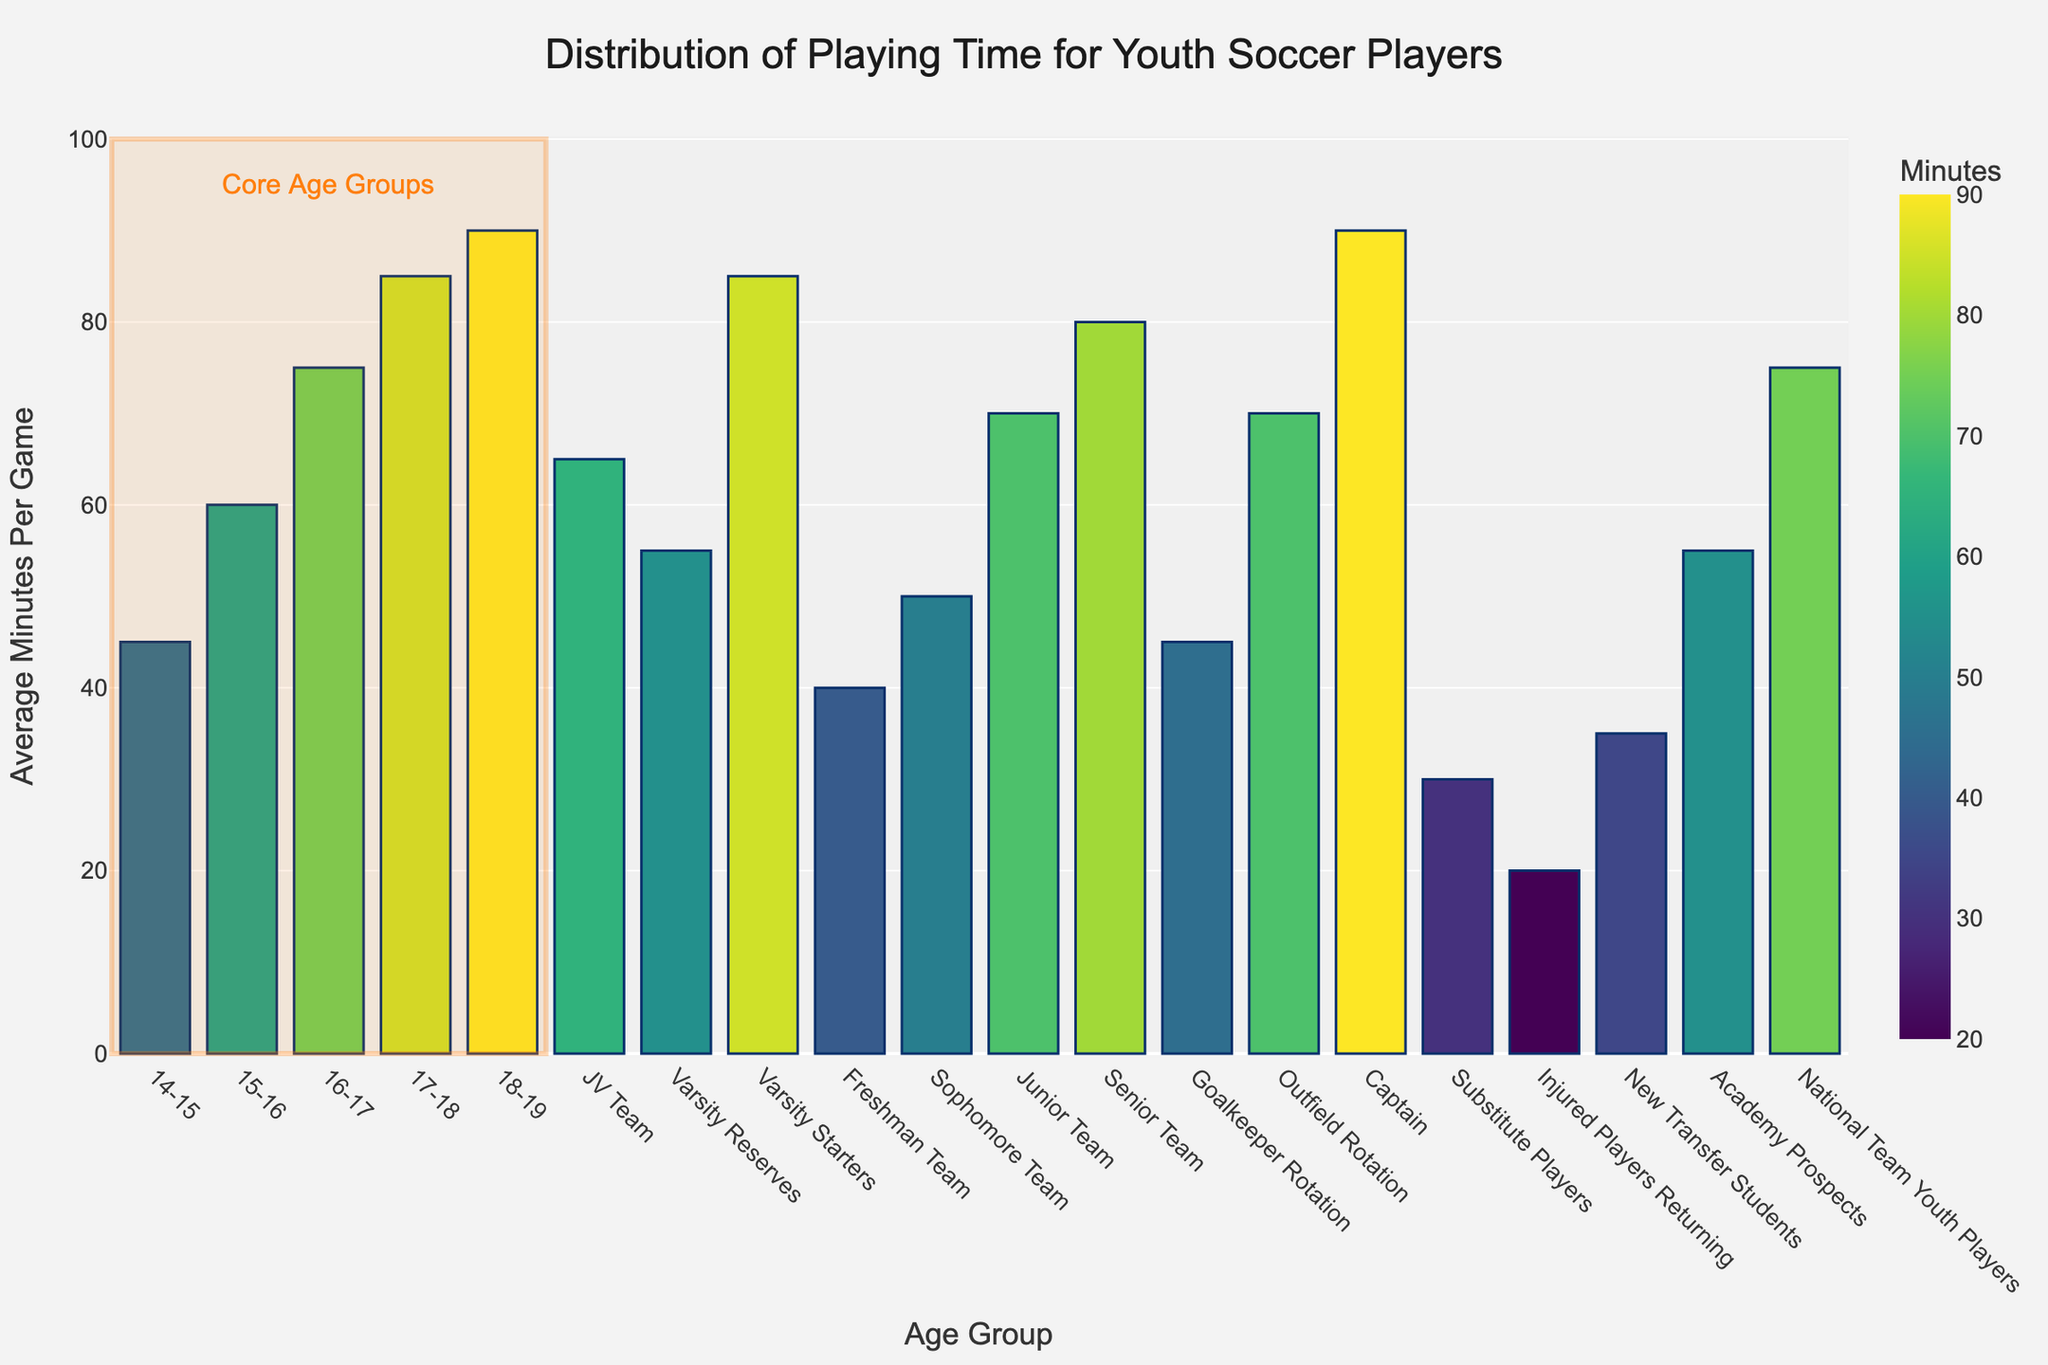What's the range of average minutes played for age-based groups? To find the range for age-based groups, identify the minimum and maximum average minutes played. The minimum is 45 (for 14-15) and the maximum is 90 (for 18-19). The range is 90 - 45.
Answer: 45 minutes Which group plays the least amount of minutes on average? Locate the bar with the smallest value on the y-axis. "Injured Players Returning" have the smallest bar, representing 20 average minutes played per game.
Answer: Injured Players Returning How much more do National Team Youth Players play compared to New Transfer Students? Find the averages for both groups: National Team Youth Players (75) and New Transfer Students (35). Subtract the smaller value from the larger: 75 - 35.
Answer: 40 minutes What is the average playing time for all the groups combined? Calculate the average by summing all the average values and dividing by the number of groups. Total sum = 45 + 60 + 75 + 85 + 90 + 65 + 55 + 85 + 40 + 50 + 70 + 80 + 45 + 70 + 90 + 30 + 20 + 35 + 55 + 75 = 1110. Number of groups = 20. Average = 1110 / 20
Answer: 55.5 minutes What is the difference in average playing time between JV Team and Varsity Reserves? Find the difference between the averages: JV Team (65) and Varsity Reserves (55). Subtract: 65 - 55.
Answer: 10 minutes Which group plays more minutes on average: Goalkeeper Rotation or Outfield Rotation? Compare the average minutes for both groups: Goalkeeper Rotation (45) vs. Outfield Rotation (70). Identify which is greater.
Answer: Outfield Rotation By how many minutes does the average playing time of Captain differ from Substitute Players? Determine the averages for both groups: Captain (90) and Substitute Players (30). Find the difference: 90 - 30.
Answer: 60 minutes Which age group has the highest average playing time? Identify the bar representing the highest value in the age-based category. The group 18-19 has the highest value at 90 average minutes per game.
Answer: 18-19 How much more does a Senior Team member play on average compared to a Freshman Team member? Locate the average minutes for both groups: Senior Team (80) and Freshman Team (40). Calculate the difference: 80 - 40.
Answer: 40 minutes What’s the combined average playing time for the Sophomore Team and Junior Team? Find the average values for both groups and add them: Sophomore Team (50) and Junior Team (70). Total = 50 + 70.
Answer: 120 minutes 